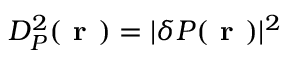Convert formula to latex. <formula><loc_0><loc_0><loc_500><loc_500>D _ { P } ^ { 2 } ( r ) = | \delta P ( r ) | ^ { 2 }</formula> 